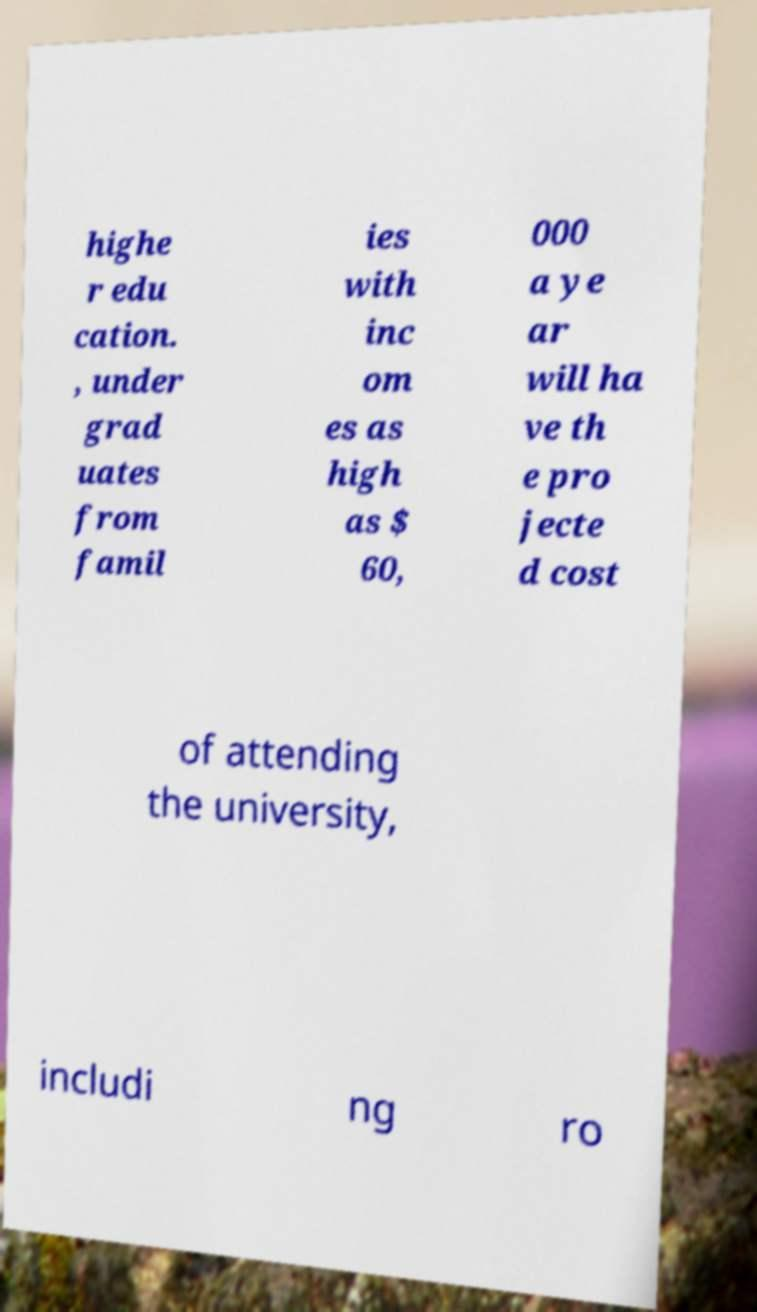For documentation purposes, I need the text within this image transcribed. Could you provide that? highe r edu cation. , under grad uates from famil ies with inc om es as high as $ 60, 000 a ye ar will ha ve th e pro jecte d cost of attending the university, includi ng ro 